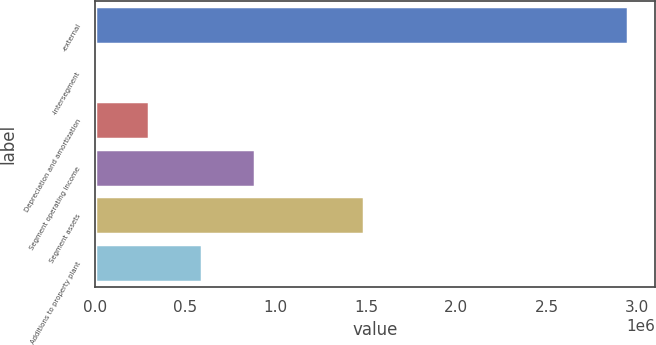Convert chart to OTSL. <chart><loc_0><loc_0><loc_500><loc_500><bar_chart><fcel>-external<fcel>-intersegment<fcel>Depreciation and amortization<fcel>Segment operating income<fcel>Segment assets<fcel>Additions to property plant<nl><fcel>2.95057e+06<fcel>3844<fcel>298517<fcel>887862<fcel>1.4907e+06<fcel>593189<nl></chart> 